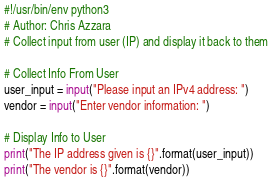<code> <loc_0><loc_0><loc_500><loc_500><_Python_>#!/usr/bin/env python3
# Author: Chris Azzara
# Collect input from user (IP) and display it back to them

# Collect Info From User
user_input = input("Please input an IPv4 address: ")
vendor = input("Enter vendor information: ")

# Display Info to User
print("The IP address given is {}".format(user_input))
print("The vendor is {}".format(vendor))
</code> 